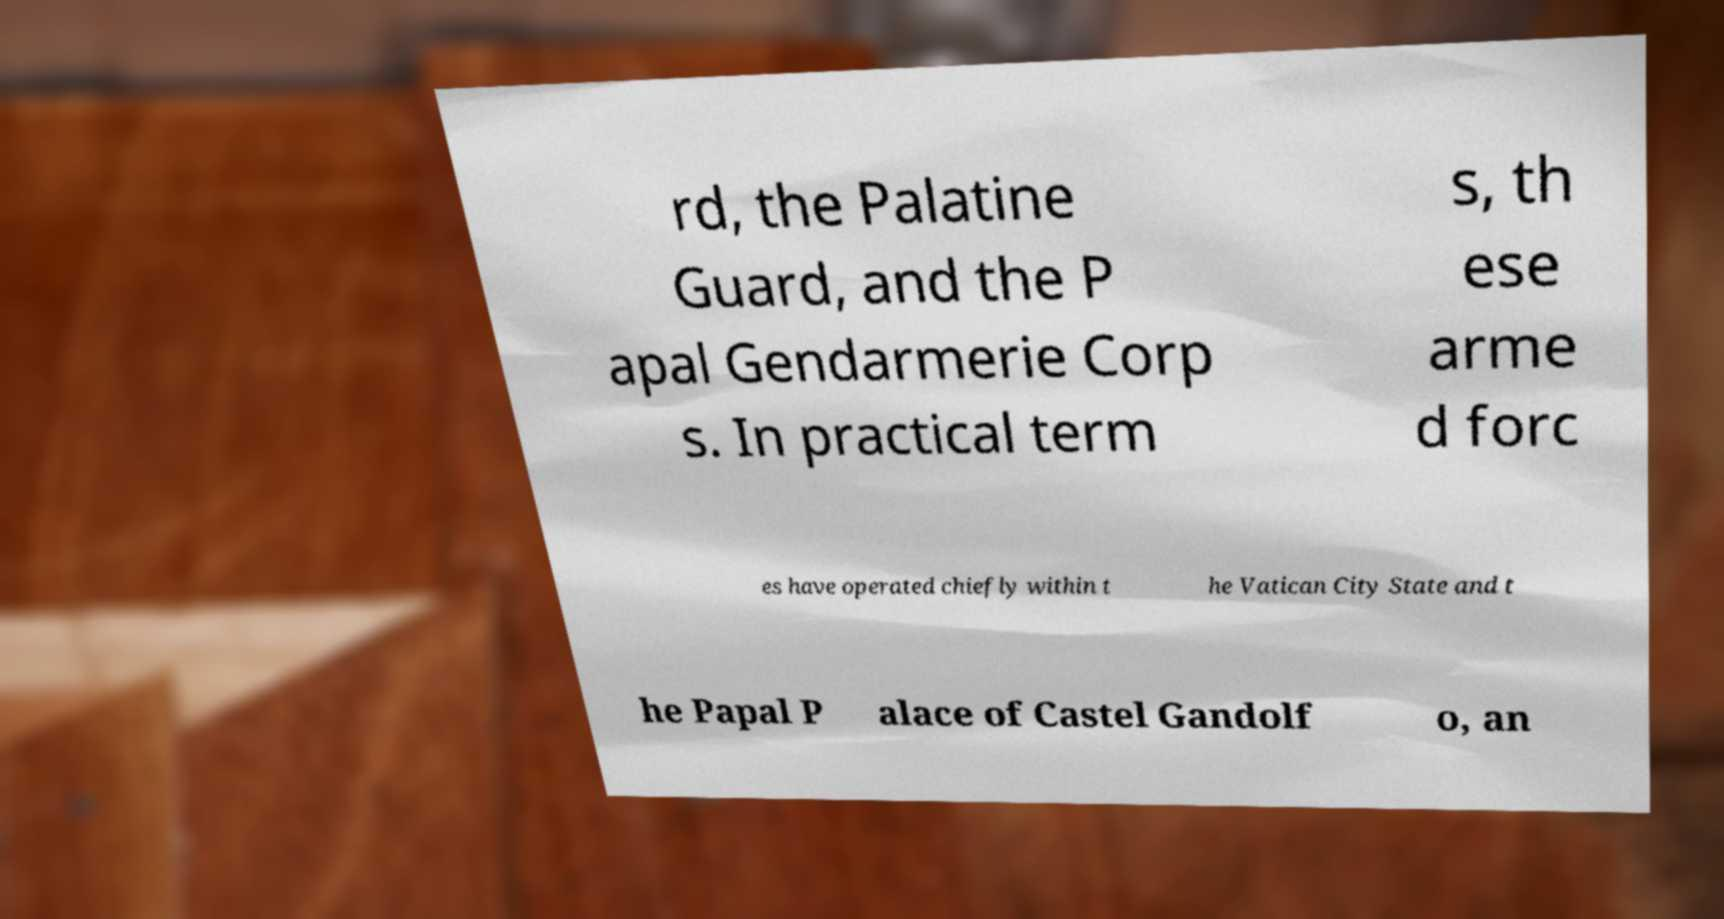I need the written content from this picture converted into text. Can you do that? rd, the Palatine Guard, and the P apal Gendarmerie Corp s. In practical term s, th ese arme d forc es have operated chiefly within t he Vatican City State and t he Papal P alace of Castel Gandolf o, an 